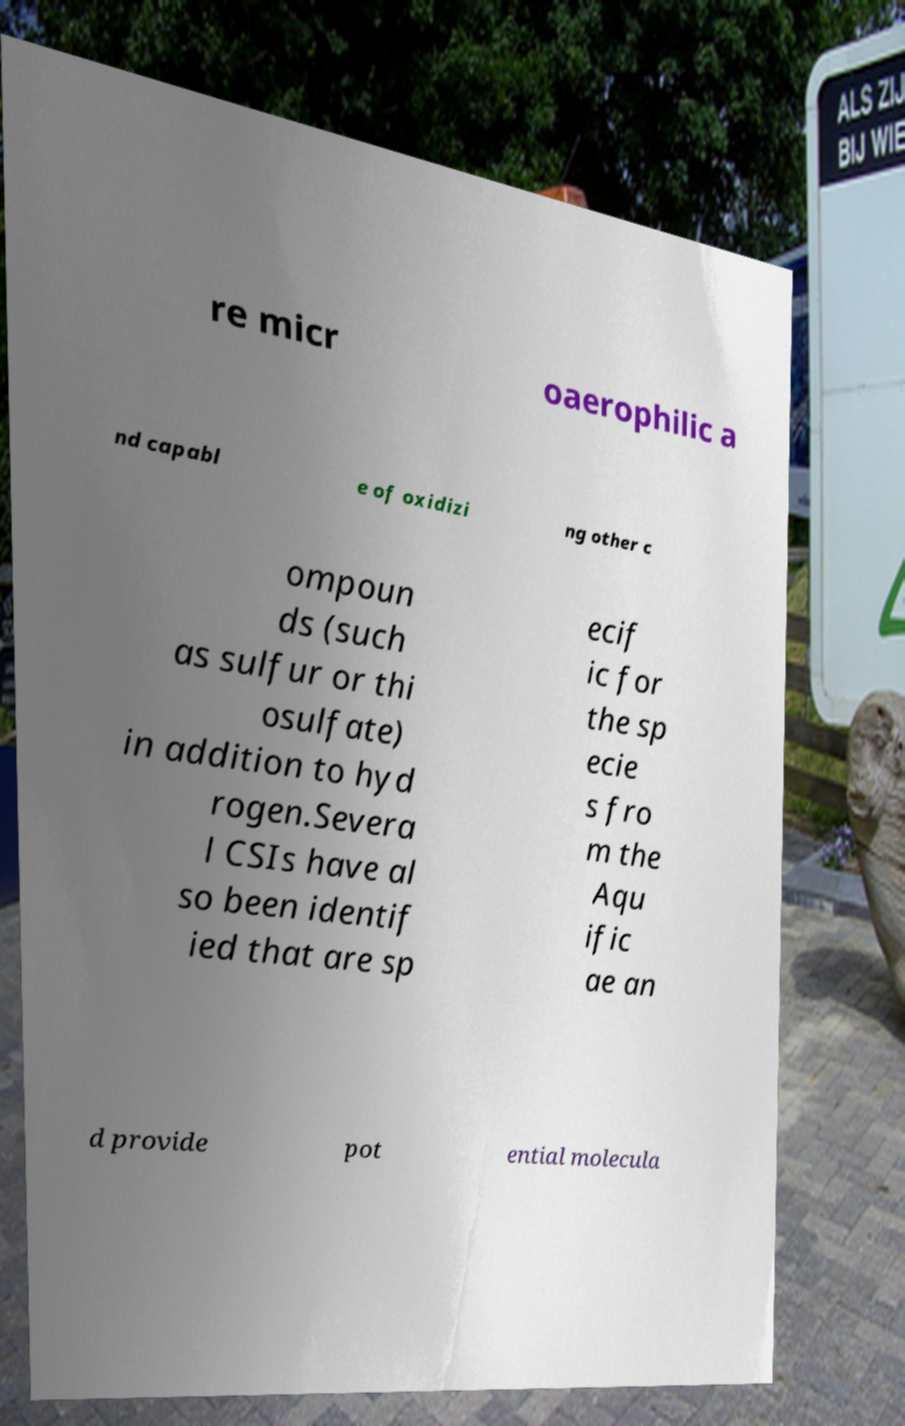Please identify and transcribe the text found in this image. re micr oaerophilic a nd capabl e of oxidizi ng other c ompoun ds (such as sulfur or thi osulfate) in addition to hyd rogen.Severa l CSIs have al so been identif ied that are sp ecif ic for the sp ecie s fro m the Aqu ific ae an d provide pot ential molecula 